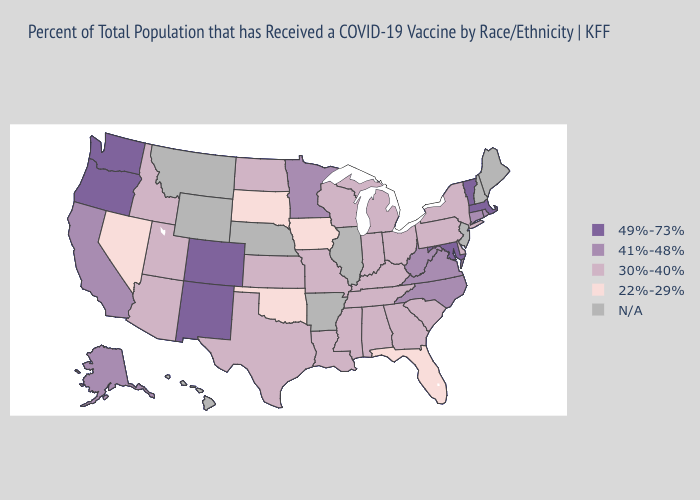What is the highest value in the USA?
Answer briefly. 49%-73%. What is the lowest value in states that border Michigan?
Answer briefly. 30%-40%. What is the lowest value in states that border New Jersey?
Give a very brief answer. 30%-40%. Does Massachusetts have the highest value in the Northeast?
Short answer required. Yes. Which states have the lowest value in the USA?
Answer briefly. Florida, Iowa, Nevada, Oklahoma, South Dakota. Does Pennsylvania have the highest value in the USA?
Answer briefly. No. What is the value of Idaho?
Give a very brief answer. 30%-40%. Name the states that have a value in the range N/A?
Write a very short answer. Arkansas, Hawaii, Illinois, Maine, Montana, Nebraska, New Hampshire, New Jersey, Wyoming. What is the value of Idaho?
Concise answer only. 30%-40%. Among the states that border Oklahoma , which have the highest value?
Write a very short answer. Colorado, New Mexico. Name the states that have a value in the range 22%-29%?
Concise answer only. Florida, Iowa, Nevada, Oklahoma, South Dakota. Does the map have missing data?
Write a very short answer. Yes. What is the value of Alabama?
Short answer required. 30%-40%. 